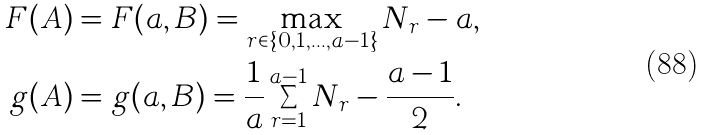<formula> <loc_0><loc_0><loc_500><loc_500>F ( A ) & = F ( a , B ) = \max _ { r \in \{ 0 , 1 , \dots , a - 1 \} } N _ { r } - a , \\ g ( A ) & = g ( a , B ) = \frac { 1 } { a } \sum _ { r = 1 } ^ { a - 1 } N _ { r } - \frac { a - 1 } { 2 } .</formula> 